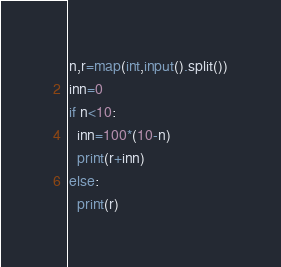<code> <loc_0><loc_0><loc_500><loc_500><_Python_>n,r=map(int,input().split())
inn=0
if n<10:
  inn=100*(10-n)
  print(r+inn)
else:
  print(r)</code> 